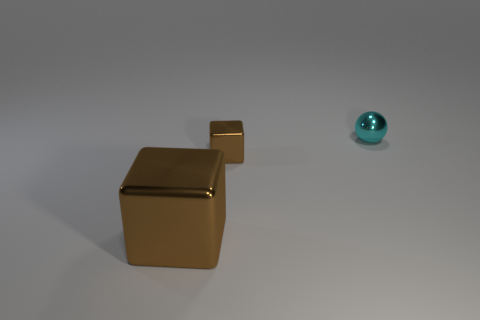What number of other things are there of the same size as the cyan object?
Ensure brevity in your answer.  1. Is the shape of the large brown object the same as the small metal thing that is in front of the metal ball?
Your answer should be compact. Yes. How many matte things are brown cubes or tiny cubes?
Provide a succinct answer. 0. Is there a shiny thing of the same color as the big shiny cube?
Make the answer very short. Yes. Are any small yellow matte cubes visible?
Make the answer very short. No. Do the small brown shiny thing and the big brown metallic object have the same shape?
Make the answer very short. Yes. What number of small objects are either cyan balls or cubes?
Provide a short and direct response. 2. The large shiny object is what color?
Keep it short and to the point. Brown. The thing that is behind the brown shiny cube behind the big block is what shape?
Your answer should be very brief. Sphere. Is there a ball made of the same material as the cyan object?
Offer a very short reply. No. 